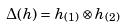<formula> <loc_0><loc_0><loc_500><loc_500>\Delta ( h ) = h _ { ( 1 ) } \otimes h _ { ( 2 ) }</formula> 